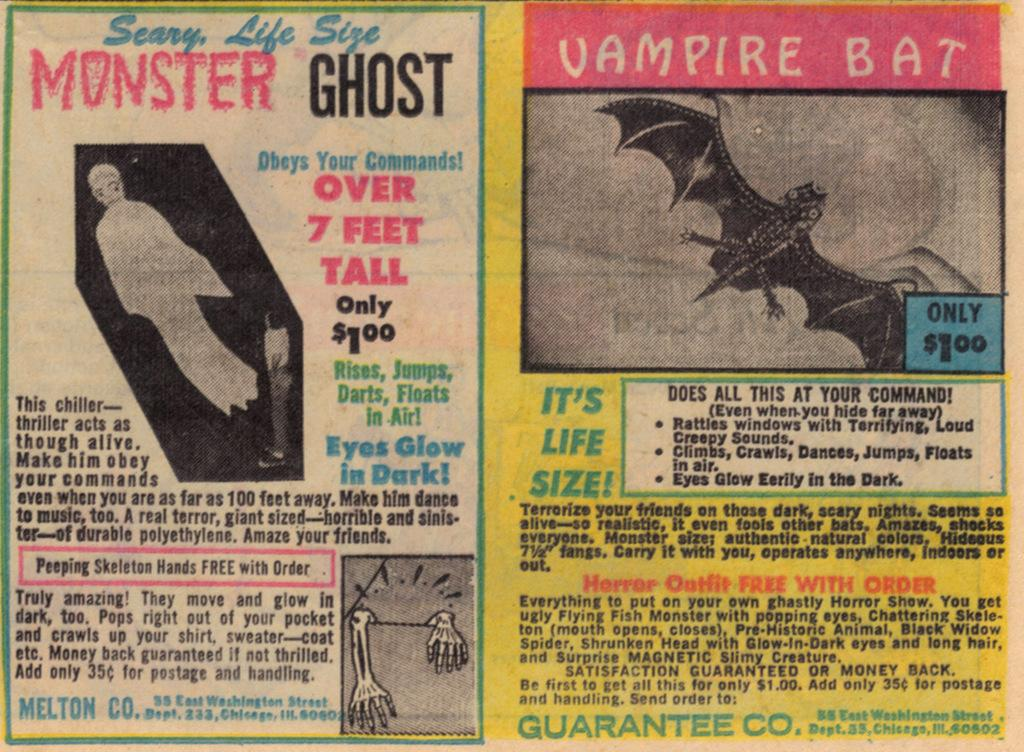<image>
Relay a brief, clear account of the picture shown. An old comic book insert that is selling s monster ghost for only one dollar. 